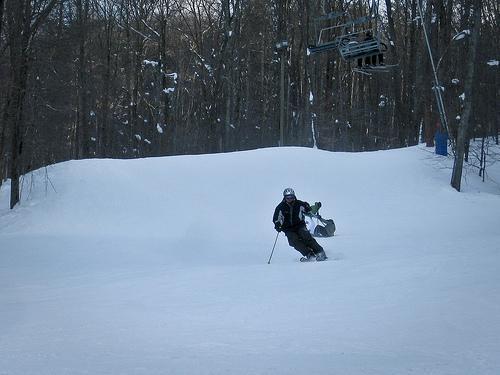How many people are there?
Give a very brief answer. 2. 